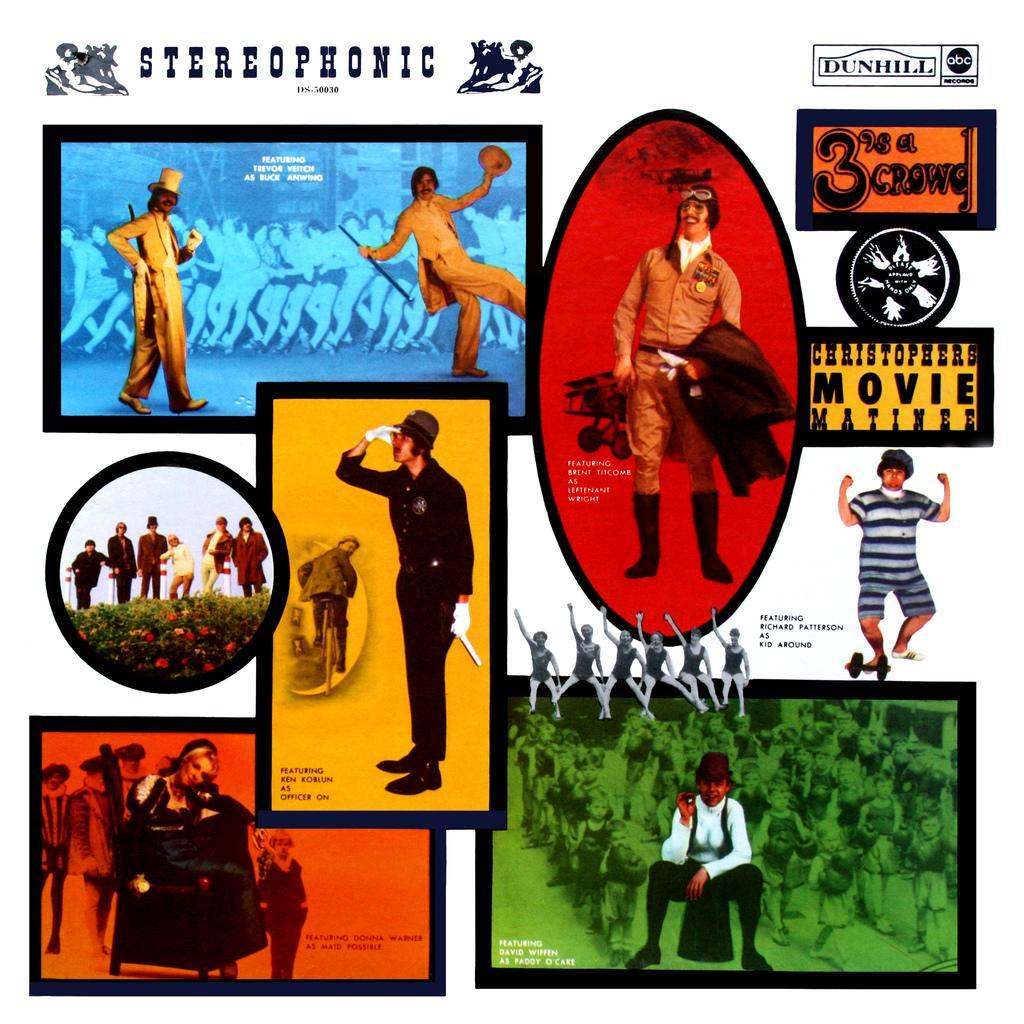How would you summarize this image in a sentence or two? We can see posts,in these posters we can see persons. 